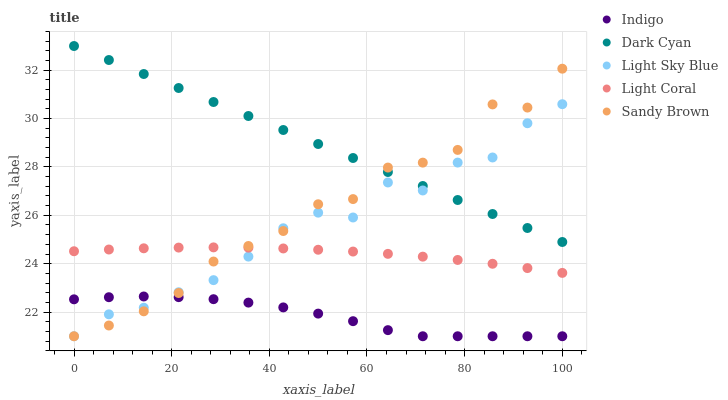Does Indigo have the minimum area under the curve?
Answer yes or no. Yes. Does Dark Cyan have the maximum area under the curve?
Answer yes or no. Yes. Does Light Coral have the minimum area under the curve?
Answer yes or no. No. Does Light Coral have the maximum area under the curve?
Answer yes or no. No. Is Dark Cyan the smoothest?
Answer yes or no. Yes. Is Light Sky Blue the roughest?
Answer yes or no. Yes. Is Light Coral the smoothest?
Answer yes or no. No. Is Light Coral the roughest?
Answer yes or no. No. Does Light Sky Blue have the lowest value?
Answer yes or no. Yes. Does Light Coral have the lowest value?
Answer yes or no. No. Does Dark Cyan have the highest value?
Answer yes or no. Yes. Does Light Coral have the highest value?
Answer yes or no. No. Is Light Coral less than Dark Cyan?
Answer yes or no. Yes. Is Dark Cyan greater than Light Coral?
Answer yes or no. Yes. Does Light Sky Blue intersect Dark Cyan?
Answer yes or no. Yes. Is Light Sky Blue less than Dark Cyan?
Answer yes or no. No. Is Light Sky Blue greater than Dark Cyan?
Answer yes or no. No. Does Light Coral intersect Dark Cyan?
Answer yes or no. No. 